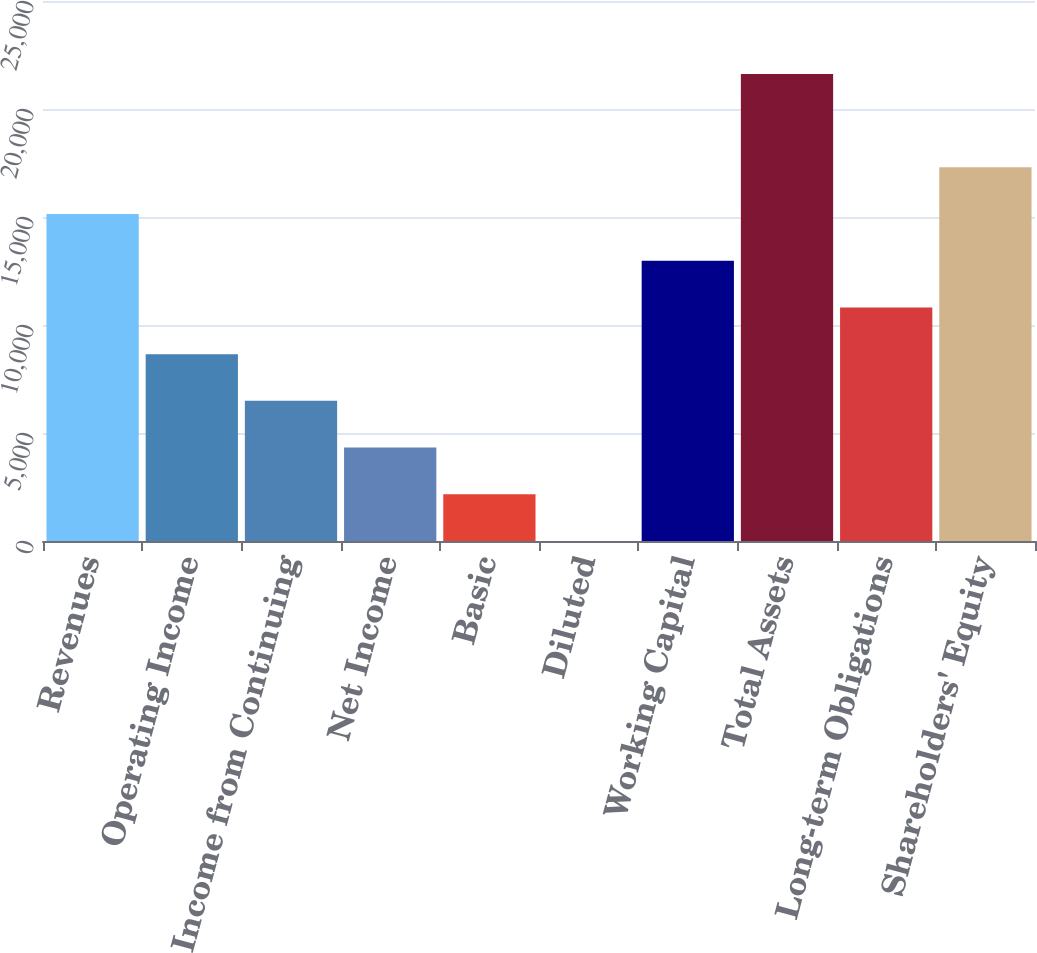<chart> <loc_0><loc_0><loc_500><loc_500><bar_chart><fcel>Revenues<fcel>Operating Income<fcel>Income from Continuing<fcel>Net Income<fcel>Basic<fcel>Diluted<fcel>Working Capital<fcel>Total Assets<fcel>Long-term Obligations<fcel>Shareholders' Equity<nl><fcel>15138.1<fcel>8651.21<fcel>6488.91<fcel>4326.61<fcel>2164.31<fcel>2.01<fcel>12975.8<fcel>21625<fcel>10813.5<fcel>17300.4<nl></chart> 